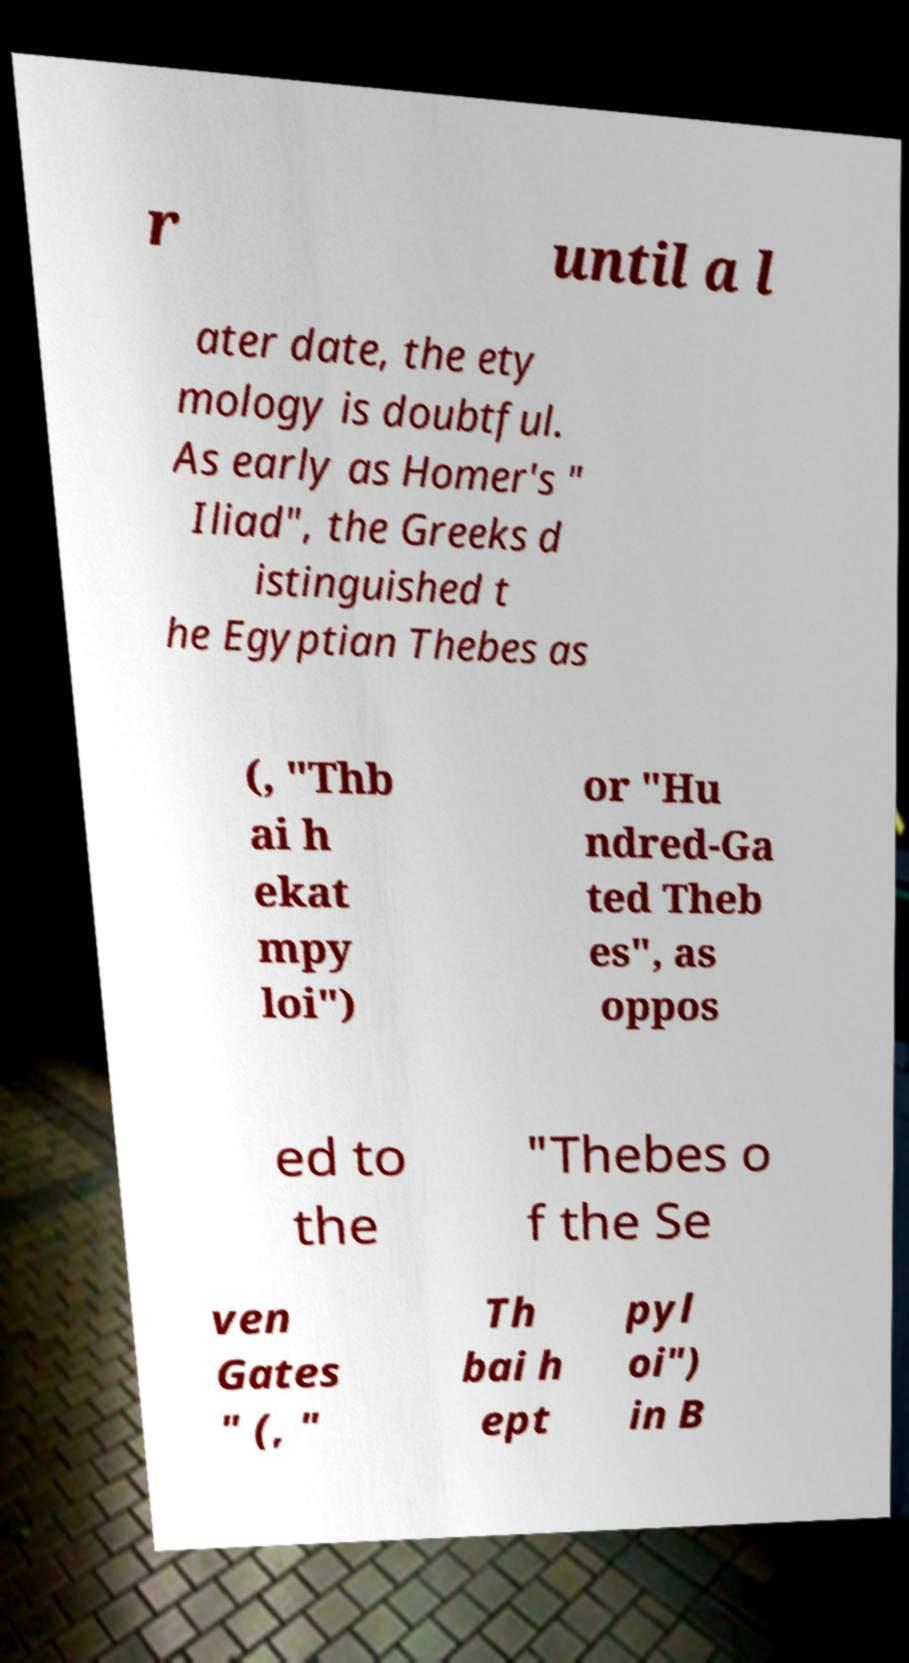Please read and relay the text visible in this image. What does it say? r until a l ater date, the ety mology is doubtful. As early as Homer's " Iliad", the Greeks d istinguished t he Egyptian Thebes as (, "Thb ai h ekat mpy loi") or "Hu ndred-Ga ted Theb es", as oppos ed to the "Thebes o f the Se ven Gates " (, " Th bai h ept pyl oi") in B 